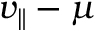<formula> <loc_0><loc_0><loc_500><loc_500>v _ { \| } - \mu</formula> 